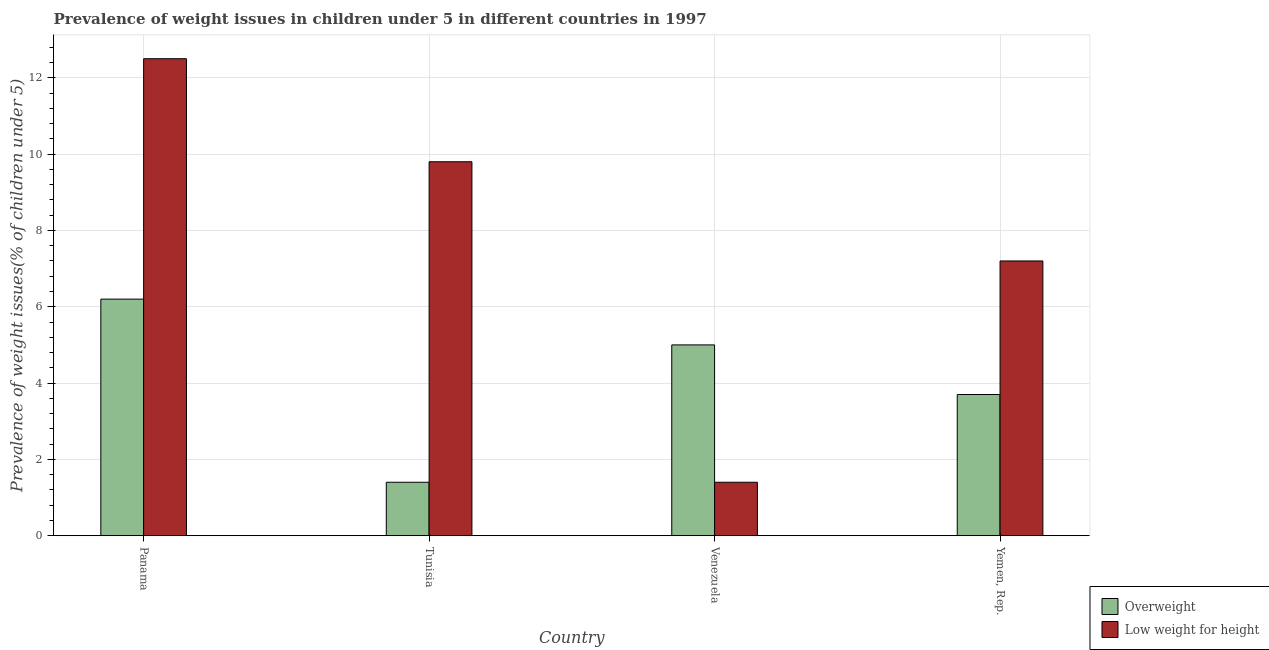How many different coloured bars are there?
Your response must be concise. 2. How many groups of bars are there?
Keep it short and to the point. 4. Are the number of bars on each tick of the X-axis equal?
Your answer should be very brief. Yes. How many bars are there on the 2nd tick from the right?
Give a very brief answer. 2. What is the label of the 3rd group of bars from the left?
Provide a short and direct response. Venezuela. What is the percentage of overweight children in Venezuela?
Ensure brevity in your answer.  5. Across all countries, what is the maximum percentage of overweight children?
Ensure brevity in your answer.  6.2. Across all countries, what is the minimum percentage of overweight children?
Your response must be concise. 1.4. In which country was the percentage of overweight children maximum?
Keep it short and to the point. Panama. In which country was the percentage of underweight children minimum?
Make the answer very short. Venezuela. What is the total percentage of overweight children in the graph?
Ensure brevity in your answer.  16.3. What is the difference between the percentage of underweight children in Panama and that in Tunisia?
Provide a succinct answer. 2.7. What is the difference between the percentage of overweight children in Tunisia and the percentage of underweight children in Venezuela?
Offer a very short reply. 0. What is the average percentage of overweight children per country?
Give a very brief answer. 4.07. What is the difference between the percentage of overweight children and percentage of underweight children in Panama?
Give a very brief answer. -6.3. What is the ratio of the percentage of overweight children in Venezuela to that in Yemen, Rep.?
Your answer should be compact. 1.35. Is the difference between the percentage of overweight children in Panama and Tunisia greater than the difference between the percentage of underweight children in Panama and Tunisia?
Your answer should be very brief. Yes. What is the difference between the highest and the second highest percentage of overweight children?
Your answer should be very brief. 1.2. What is the difference between the highest and the lowest percentage of underweight children?
Keep it short and to the point. 11.1. What does the 2nd bar from the left in Panama represents?
Your answer should be compact. Low weight for height. What does the 1st bar from the right in Venezuela represents?
Provide a short and direct response. Low weight for height. How many bars are there?
Provide a succinct answer. 8. What is the difference between two consecutive major ticks on the Y-axis?
Your response must be concise. 2. Are the values on the major ticks of Y-axis written in scientific E-notation?
Your response must be concise. No. What is the title of the graph?
Your answer should be compact. Prevalence of weight issues in children under 5 in different countries in 1997. Does "International Visitors" appear as one of the legend labels in the graph?
Provide a short and direct response. No. What is the label or title of the Y-axis?
Ensure brevity in your answer.  Prevalence of weight issues(% of children under 5). What is the Prevalence of weight issues(% of children under 5) of Overweight in Panama?
Your response must be concise. 6.2. What is the Prevalence of weight issues(% of children under 5) of Overweight in Tunisia?
Ensure brevity in your answer.  1.4. What is the Prevalence of weight issues(% of children under 5) in Low weight for height in Tunisia?
Make the answer very short. 9.8. What is the Prevalence of weight issues(% of children under 5) of Low weight for height in Venezuela?
Keep it short and to the point. 1.4. What is the Prevalence of weight issues(% of children under 5) of Overweight in Yemen, Rep.?
Your response must be concise. 3.7. What is the Prevalence of weight issues(% of children under 5) of Low weight for height in Yemen, Rep.?
Offer a very short reply. 7.2. Across all countries, what is the maximum Prevalence of weight issues(% of children under 5) of Overweight?
Offer a very short reply. 6.2. Across all countries, what is the maximum Prevalence of weight issues(% of children under 5) in Low weight for height?
Your response must be concise. 12.5. Across all countries, what is the minimum Prevalence of weight issues(% of children under 5) in Overweight?
Ensure brevity in your answer.  1.4. Across all countries, what is the minimum Prevalence of weight issues(% of children under 5) in Low weight for height?
Provide a short and direct response. 1.4. What is the total Prevalence of weight issues(% of children under 5) of Low weight for height in the graph?
Provide a short and direct response. 30.9. What is the difference between the Prevalence of weight issues(% of children under 5) of Overweight in Panama and that in Tunisia?
Your answer should be very brief. 4.8. What is the difference between the Prevalence of weight issues(% of children under 5) of Low weight for height in Panama and that in Tunisia?
Your answer should be compact. 2.7. What is the difference between the Prevalence of weight issues(% of children under 5) in Overweight in Panama and that in Venezuela?
Your answer should be very brief. 1.2. What is the difference between the Prevalence of weight issues(% of children under 5) of Low weight for height in Panama and that in Yemen, Rep.?
Provide a short and direct response. 5.3. What is the difference between the Prevalence of weight issues(% of children under 5) of Overweight in Tunisia and that in Venezuela?
Give a very brief answer. -3.6. What is the difference between the Prevalence of weight issues(% of children under 5) in Low weight for height in Tunisia and that in Venezuela?
Your answer should be compact. 8.4. What is the difference between the Prevalence of weight issues(% of children under 5) in Overweight in Venezuela and that in Yemen, Rep.?
Ensure brevity in your answer.  1.3. What is the difference between the Prevalence of weight issues(% of children under 5) of Low weight for height in Venezuela and that in Yemen, Rep.?
Make the answer very short. -5.8. What is the difference between the Prevalence of weight issues(% of children under 5) of Overweight in Panama and the Prevalence of weight issues(% of children under 5) of Low weight for height in Venezuela?
Provide a short and direct response. 4.8. What is the difference between the Prevalence of weight issues(% of children under 5) in Overweight in Tunisia and the Prevalence of weight issues(% of children under 5) in Low weight for height in Yemen, Rep.?
Your response must be concise. -5.8. What is the difference between the Prevalence of weight issues(% of children under 5) in Overweight in Venezuela and the Prevalence of weight issues(% of children under 5) in Low weight for height in Yemen, Rep.?
Provide a succinct answer. -2.2. What is the average Prevalence of weight issues(% of children under 5) of Overweight per country?
Ensure brevity in your answer.  4.08. What is the average Prevalence of weight issues(% of children under 5) of Low weight for height per country?
Your response must be concise. 7.72. What is the difference between the Prevalence of weight issues(% of children under 5) in Overweight and Prevalence of weight issues(% of children under 5) in Low weight for height in Panama?
Provide a succinct answer. -6.3. What is the difference between the Prevalence of weight issues(% of children under 5) in Overweight and Prevalence of weight issues(% of children under 5) in Low weight for height in Tunisia?
Keep it short and to the point. -8.4. What is the difference between the Prevalence of weight issues(% of children under 5) of Overweight and Prevalence of weight issues(% of children under 5) of Low weight for height in Venezuela?
Your answer should be very brief. 3.6. What is the difference between the Prevalence of weight issues(% of children under 5) in Overweight and Prevalence of weight issues(% of children under 5) in Low weight for height in Yemen, Rep.?
Keep it short and to the point. -3.5. What is the ratio of the Prevalence of weight issues(% of children under 5) of Overweight in Panama to that in Tunisia?
Ensure brevity in your answer.  4.43. What is the ratio of the Prevalence of weight issues(% of children under 5) of Low weight for height in Panama to that in Tunisia?
Offer a very short reply. 1.28. What is the ratio of the Prevalence of weight issues(% of children under 5) in Overweight in Panama to that in Venezuela?
Give a very brief answer. 1.24. What is the ratio of the Prevalence of weight issues(% of children under 5) of Low weight for height in Panama to that in Venezuela?
Your answer should be compact. 8.93. What is the ratio of the Prevalence of weight issues(% of children under 5) of Overweight in Panama to that in Yemen, Rep.?
Give a very brief answer. 1.68. What is the ratio of the Prevalence of weight issues(% of children under 5) of Low weight for height in Panama to that in Yemen, Rep.?
Your response must be concise. 1.74. What is the ratio of the Prevalence of weight issues(% of children under 5) of Overweight in Tunisia to that in Venezuela?
Your answer should be compact. 0.28. What is the ratio of the Prevalence of weight issues(% of children under 5) of Low weight for height in Tunisia to that in Venezuela?
Ensure brevity in your answer.  7. What is the ratio of the Prevalence of weight issues(% of children under 5) of Overweight in Tunisia to that in Yemen, Rep.?
Make the answer very short. 0.38. What is the ratio of the Prevalence of weight issues(% of children under 5) of Low weight for height in Tunisia to that in Yemen, Rep.?
Your answer should be compact. 1.36. What is the ratio of the Prevalence of weight issues(% of children under 5) of Overweight in Venezuela to that in Yemen, Rep.?
Offer a terse response. 1.35. What is the ratio of the Prevalence of weight issues(% of children under 5) of Low weight for height in Venezuela to that in Yemen, Rep.?
Your answer should be compact. 0.19. What is the difference between the highest and the lowest Prevalence of weight issues(% of children under 5) of Overweight?
Your answer should be compact. 4.8. 